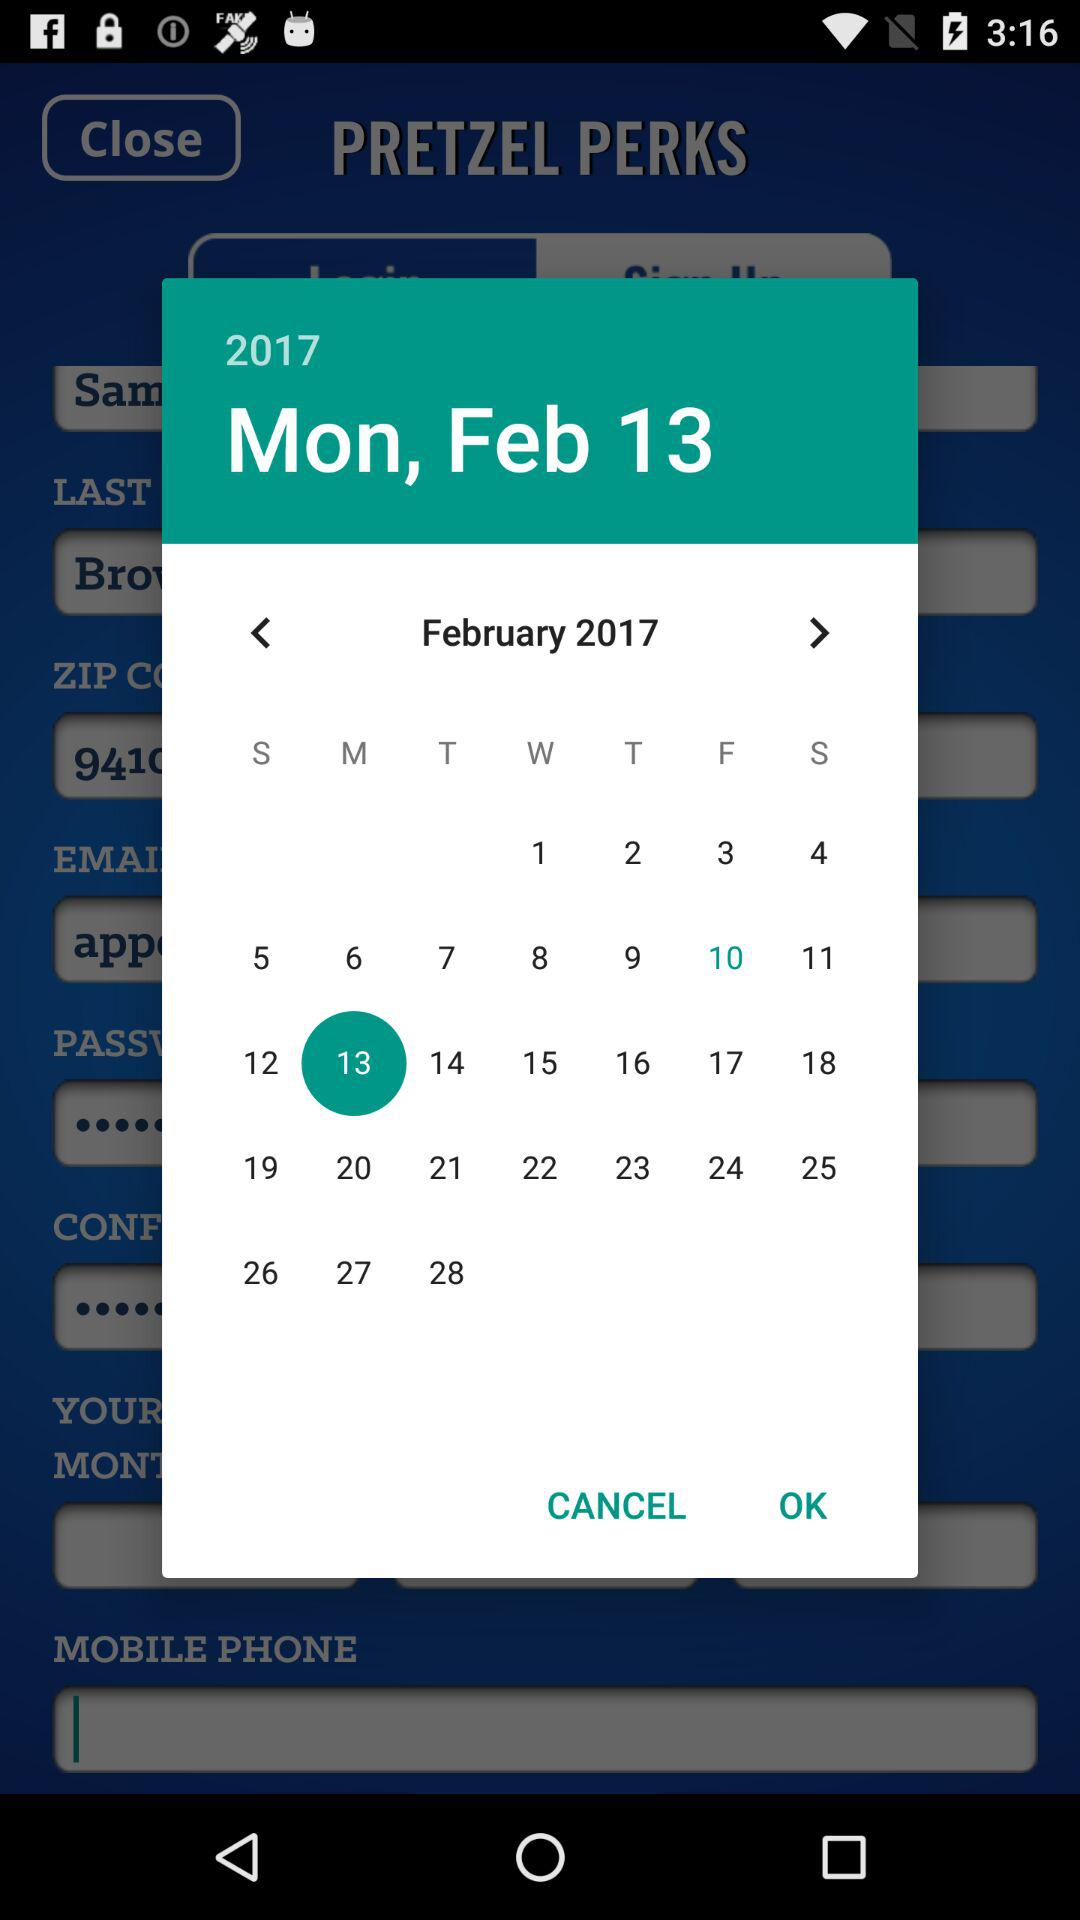Which year and month are selected on the calendar? The selected year and month are 2017 and February, respectively. 